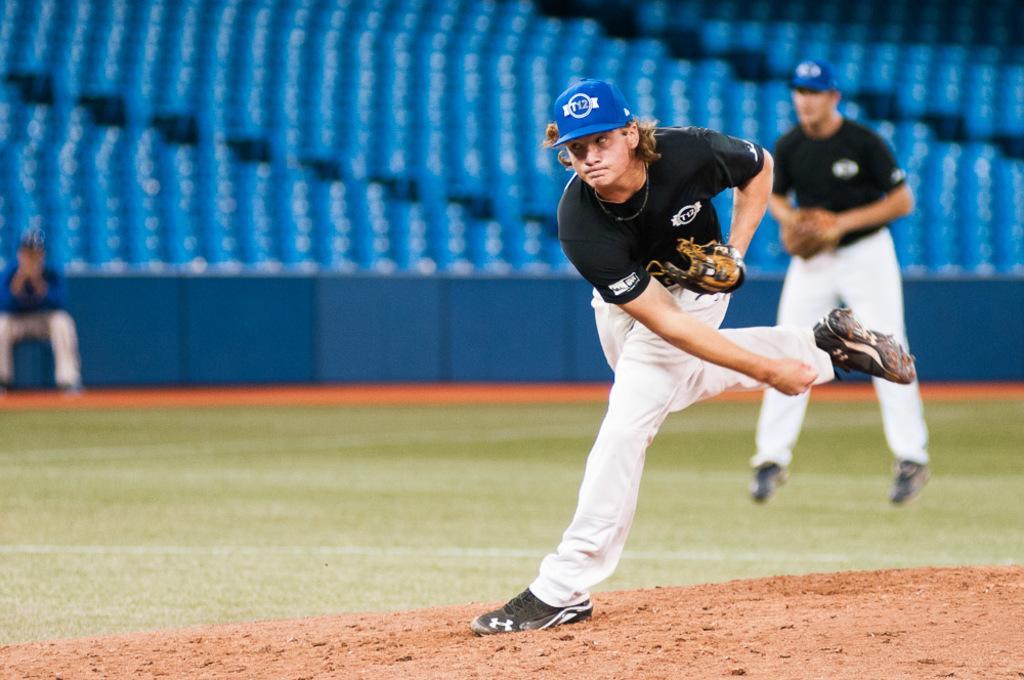Could you give a brief overview of what you see in this image? In this image, we can see two people in the playground, in the background, we can see blue color chairs. 